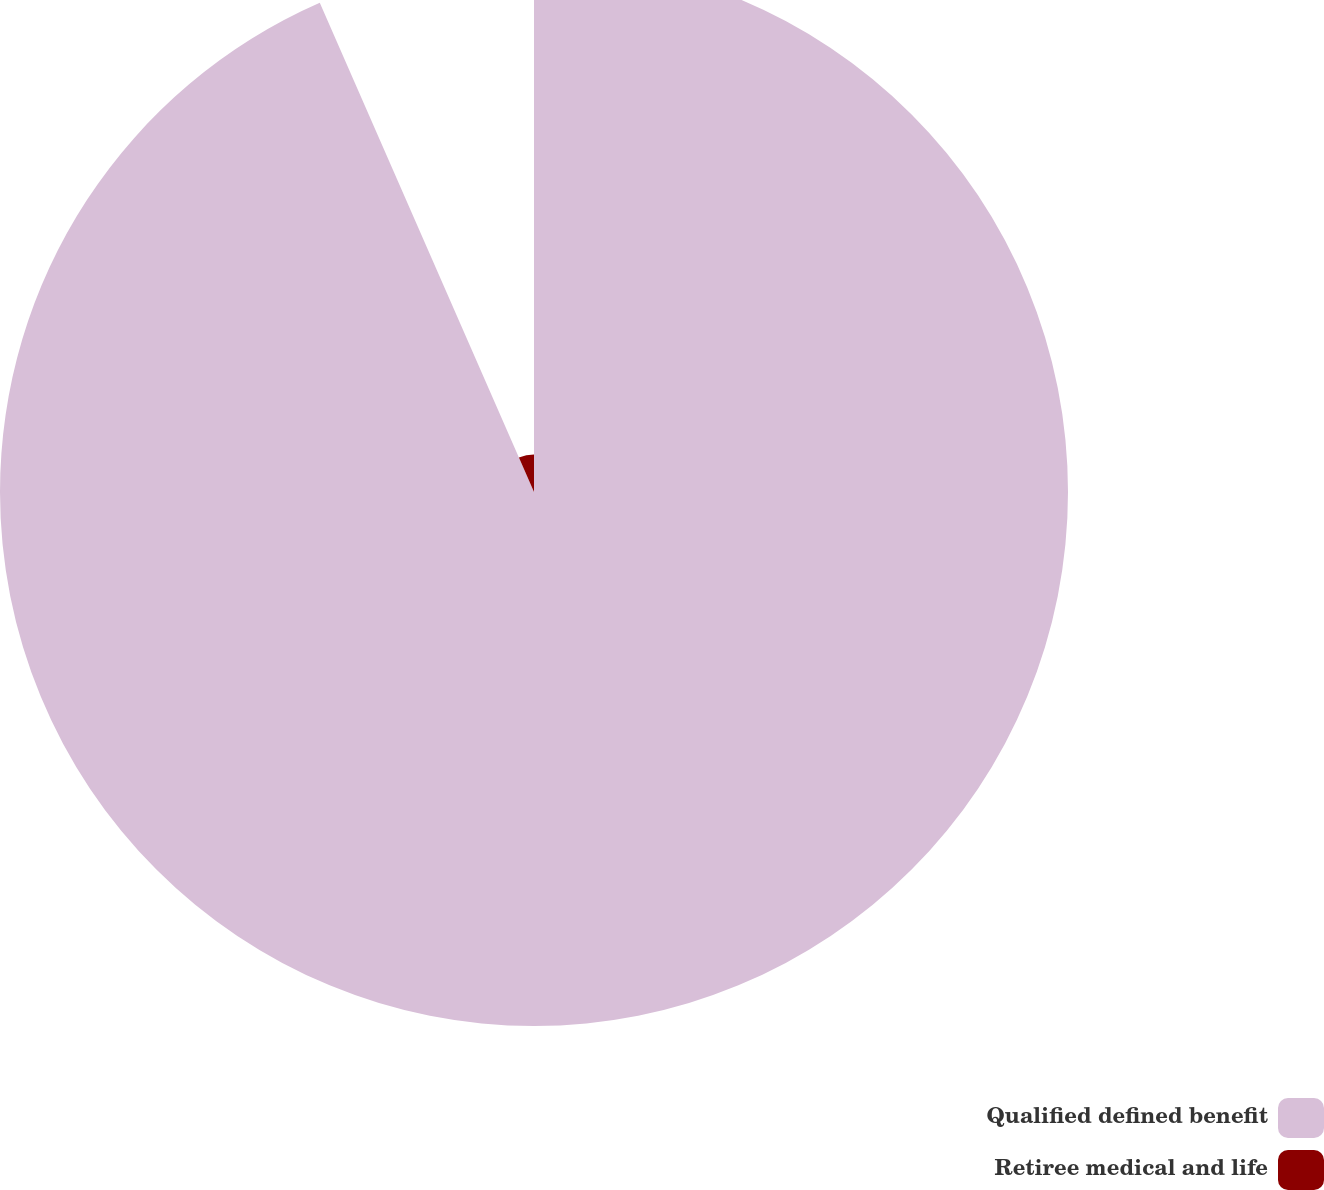<chart> <loc_0><loc_0><loc_500><loc_500><pie_chart><fcel>Qualified defined benefit<fcel>Retiree medical and life<nl><fcel>93.43%<fcel>6.57%<nl></chart> 